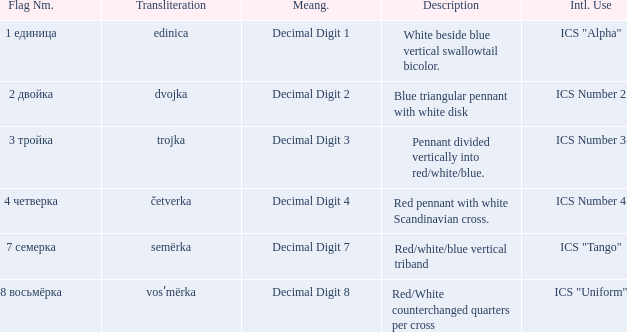How many different descriptions are there for the flag that means decimal digit 2? 1.0. 